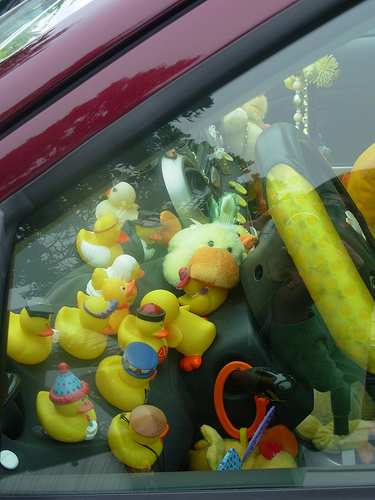<image>
Can you confirm if the duck is behind the duck? Yes. From this viewpoint, the duck is positioned behind the duck, with the duck partially or fully occluding the duck. 